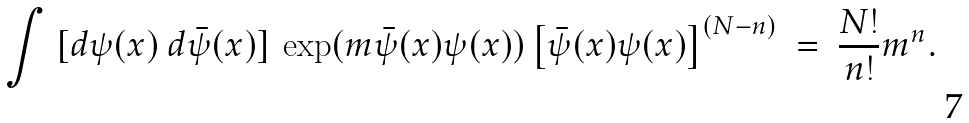<formula> <loc_0><loc_0><loc_500><loc_500>\int \ [ d \psi ( x ) \ d \bar { \psi } ( x ) ] \ \exp ( m \bar { \psi } ( x ) \psi ( x ) ) \left [ \bar { \psi } ( x ) \psi ( x ) \right ] ^ { ( N - n ) } \ = \ \frac { N ! } { n ! } m ^ { n } .</formula> 